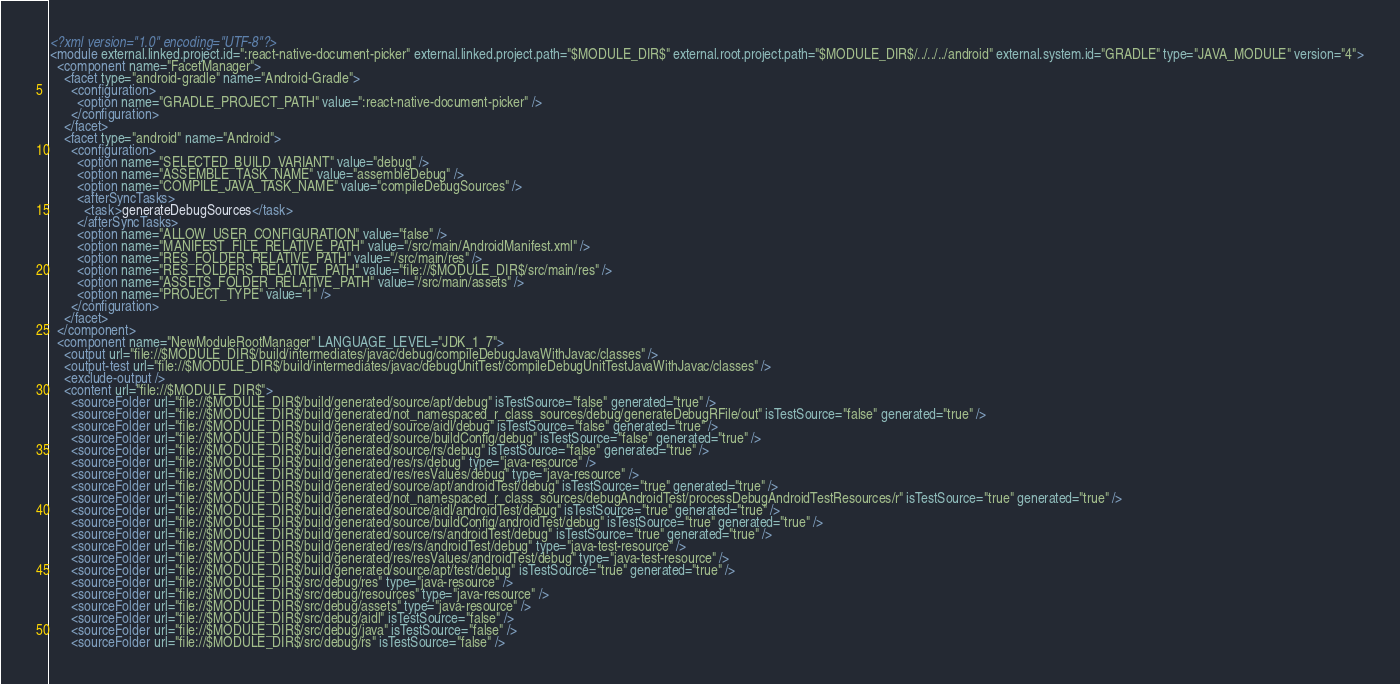Convert code to text. <code><loc_0><loc_0><loc_500><loc_500><_XML_><?xml version="1.0" encoding="UTF-8"?>
<module external.linked.project.id=":react-native-document-picker" external.linked.project.path="$MODULE_DIR$" external.root.project.path="$MODULE_DIR$/../../../android" external.system.id="GRADLE" type="JAVA_MODULE" version="4">
  <component name="FacetManager">
    <facet type="android-gradle" name="Android-Gradle">
      <configuration>
        <option name="GRADLE_PROJECT_PATH" value=":react-native-document-picker" />
      </configuration>
    </facet>
    <facet type="android" name="Android">
      <configuration>
        <option name="SELECTED_BUILD_VARIANT" value="debug" />
        <option name="ASSEMBLE_TASK_NAME" value="assembleDebug" />
        <option name="COMPILE_JAVA_TASK_NAME" value="compileDebugSources" />
        <afterSyncTasks>
          <task>generateDebugSources</task>
        </afterSyncTasks>
        <option name="ALLOW_USER_CONFIGURATION" value="false" />
        <option name="MANIFEST_FILE_RELATIVE_PATH" value="/src/main/AndroidManifest.xml" />
        <option name="RES_FOLDER_RELATIVE_PATH" value="/src/main/res" />
        <option name="RES_FOLDERS_RELATIVE_PATH" value="file://$MODULE_DIR$/src/main/res" />
        <option name="ASSETS_FOLDER_RELATIVE_PATH" value="/src/main/assets" />
        <option name="PROJECT_TYPE" value="1" />
      </configuration>
    </facet>
  </component>
  <component name="NewModuleRootManager" LANGUAGE_LEVEL="JDK_1_7">
    <output url="file://$MODULE_DIR$/build/intermediates/javac/debug/compileDebugJavaWithJavac/classes" />
    <output-test url="file://$MODULE_DIR$/build/intermediates/javac/debugUnitTest/compileDebugUnitTestJavaWithJavac/classes" />
    <exclude-output />
    <content url="file://$MODULE_DIR$">
      <sourceFolder url="file://$MODULE_DIR$/build/generated/source/apt/debug" isTestSource="false" generated="true" />
      <sourceFolder url="file://$MODULE_DIR$/build/generated/not_namespaced_r_class_sources/debug/generateDebugRFile/out" isTestSource="false" generated="true" />
      <sourceFolder url="file://$MODULE_DIR$/build/generated/source/aidl/debug" isTestSource="false" generated="true" />
      <sourceFolder url="file://$MODULE_DIR$/build/generated/source/buildConfig/debug" isTestSource="false" generated="true" />
      <sourceFolder url="file://$MODULE_DIR$/build/generated/source/rs/debug" isTestSource="false" generated="true" />
      <sourceFolder url="file://$MODULE_DIR$/build/generated/res/rs/debug" type="java-resource" />
      <sourceFolder url="file://$MODULE_DIR$/build/generated/res/resValues/debug" type="java-resource" />
      <sourceFolder url="file://$MODULE_DIR$/build/generated/source/apt/androidTest/debug" isTestSource="true" generated="true" />
      <sourceFolder url="file://$MODULE_DIR$/build/generated/not_namespaced_r_class_sources/debugAndroidTest/processDebugAndroidTestResources/r" isTestSource="true" generated="true" />
      <sourceFolder url="file://$MODULE_DIR$/build/generated/source/aidl/androidTest/debug" isTestSource="true" generated="true" />
      <sourceFolder url="file://$MODULE_DIR$/build/generated/source/buildConfig/androidTest/debug" isTestSource="true" generated="true" />
      <sourceFolder url="file://$MODULE_DIR$/build/generated/source/rs/androidTest/debug" isTestSource="true" generated="true" />
      <sourceFolder url="file://$MODULE_DIR$/build/generated/res/rs/androidTest/debug" type="java-test-resource" />
      <sourceFolder url="file://$MODULE_DIR$/build/generated/res/resValues/androidTest/debug" type="java-test-resource" />
      <sourceFolder url="file://$MODULE_DIR$/build/generated/source/apt/test/debug" isTestSource="true" generated="true" />
      <sourceFolder url="file://$MODULE_DIR$/src/debug/res" type="java-resource" />
      <sourceFolder url="file://$MODULE_DIR$/src/debug/resources" type="java-resource" />
      <sourceFolder url="file://$MODULE_DIR$/src/debug/assets" type="java-resource" />
      <sourceFolder url="file://$MODULE_DIR$/src/debug/aidl" isTestSource="false" />
      <sourceFolder url="file://$MODULE_DIR$/src/debug/java" isTestSource="false" />
      <sourceFolder url="file://$MODULE_DIR$/src/debug/rs" isTestSource="false" /></code> 